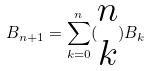Convert formula to latex. <formula><loc_0><loc_0><loc_500><loc_500>B _ { n + 1 } = \sum _ { k = 0 } ^ { n } ( \begin{matrix} n \\ k \end{matrix} ) B _ { k }</formula> 